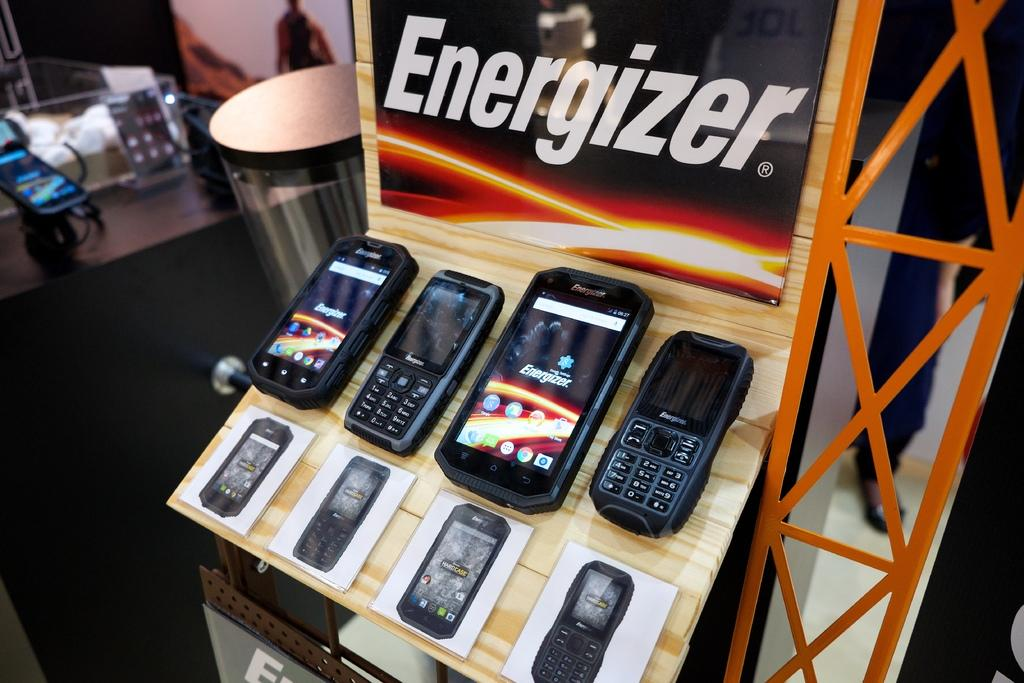<image>
Write a terse but informative summary of the picture. Four mobile phones on display made by Energizer. 